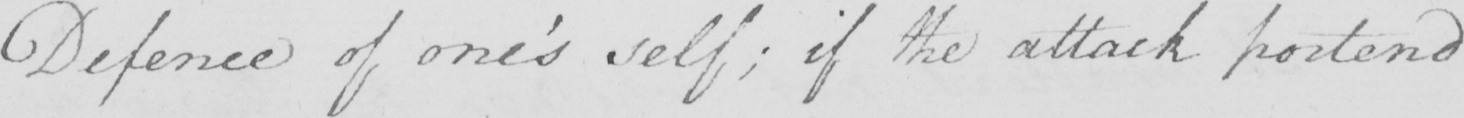Transcribe the text shown in this historical manuscript line. Defence of one ' s self ; if the attack portend 